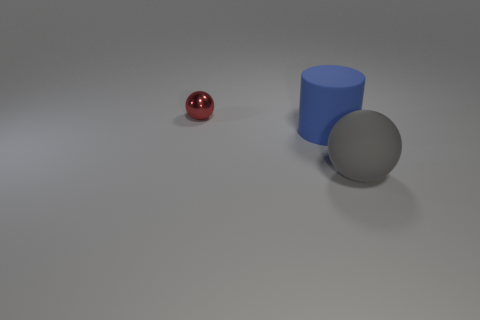How many other things are the same material as the large blue thing?
Your answer should be compact. 1. Is the number of large brown cylinders greater than the number of gray rubber things?
Offer a very short reply. No. The sphere left of the ball that is to the right of the tiny metallic thing that is on the left side of the gray thing is made of what material?
Give a very brief answer. Metal. Are there any big rubber spheres of the same color as the metal object?
Your answer should be compact. No. What is the shape of the object that is the same size as the blue matte cylinder?
Give a very brief answer. Sphere. Is the number of big gray rubber objects less than the number of small purple spheres?
Your answer should be compact. No. How many red shiny things have the same size as the blue rubber thing?
Your answer should be compact. 0. What is the material of the large blue object?
Keep it short and to the point. Rubber. There is a ball that is behind the big matte cylinder; what is its size?
Your response must be concise. Small. What number of red shiny objects are the same shape as the large gray matte thing?
Give a very brief answer. 1. 